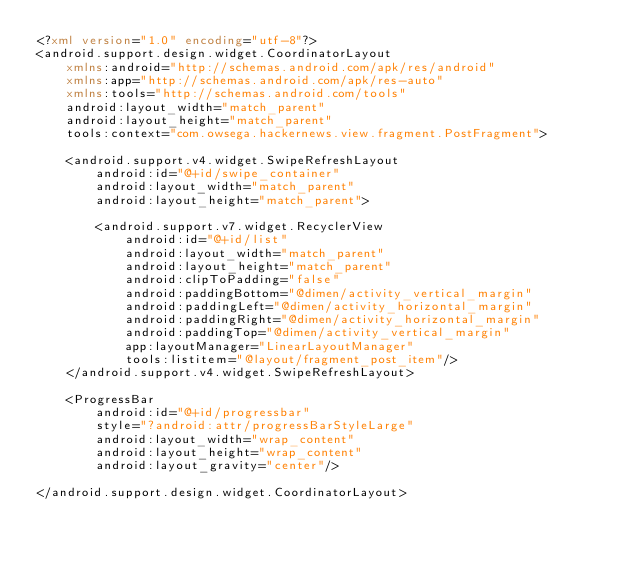Convert code to text. <code><loc_0><loc_0><loc_500><loc_500><_XML_><?xml version="1.0" encoding="utf-8"?>
<android.support.design.widget.CoordinatorLayout
    xmlns:android="http://schemas.android.com/apk/res/android"
    xmlns:app="http://schemas.android.com/apk/res-auto"
    xmlns:tools="http://schemas.android.com/tools"
    android:layout_width="match_parent"
    android:layout_height="match_parent"
    tools:context="com.owsega.hackernews.view.fragment.PostFragment">

    <android.support.v4.widget.SwipeRefreshLayout
        android:id="@+id/swipe_container"
        android:layout_width="match_parent"
        android:layout_height="match_parent">

        <android.support.v7.widget.RecyclerView
            android:id="@+id/list"
            android:layout_width="match_parent"
            android:layout_height="match_parent"
            android:clipToPadding="false"
            android:paddingBottom="@dimen/activity_vertical_margin"
            android:paddingLeft="@dimen/activity_horizontal_margin"
            android:paddingRight="@dimen/activity_horizontal_margin"
            android:paddingTop="@dimen/activity_vertical_margin"
            app:layoutManager="LinearLayoutManager"
            tools:listitem="@layout/fragment_post_item"/>
    </android.support.v4.widget.SwipeRefreshLayout>

    <ProgressBar
        android:id="@+id/progressbar"
        style="?android:attr/progressBarStyleLarge"
        android:layout_width="wrap_content"
        android:layout_height="wrap_content"
        android:layout_gravity="center"/>

</android.support.design.widget.CoordinatorLayout></code> 